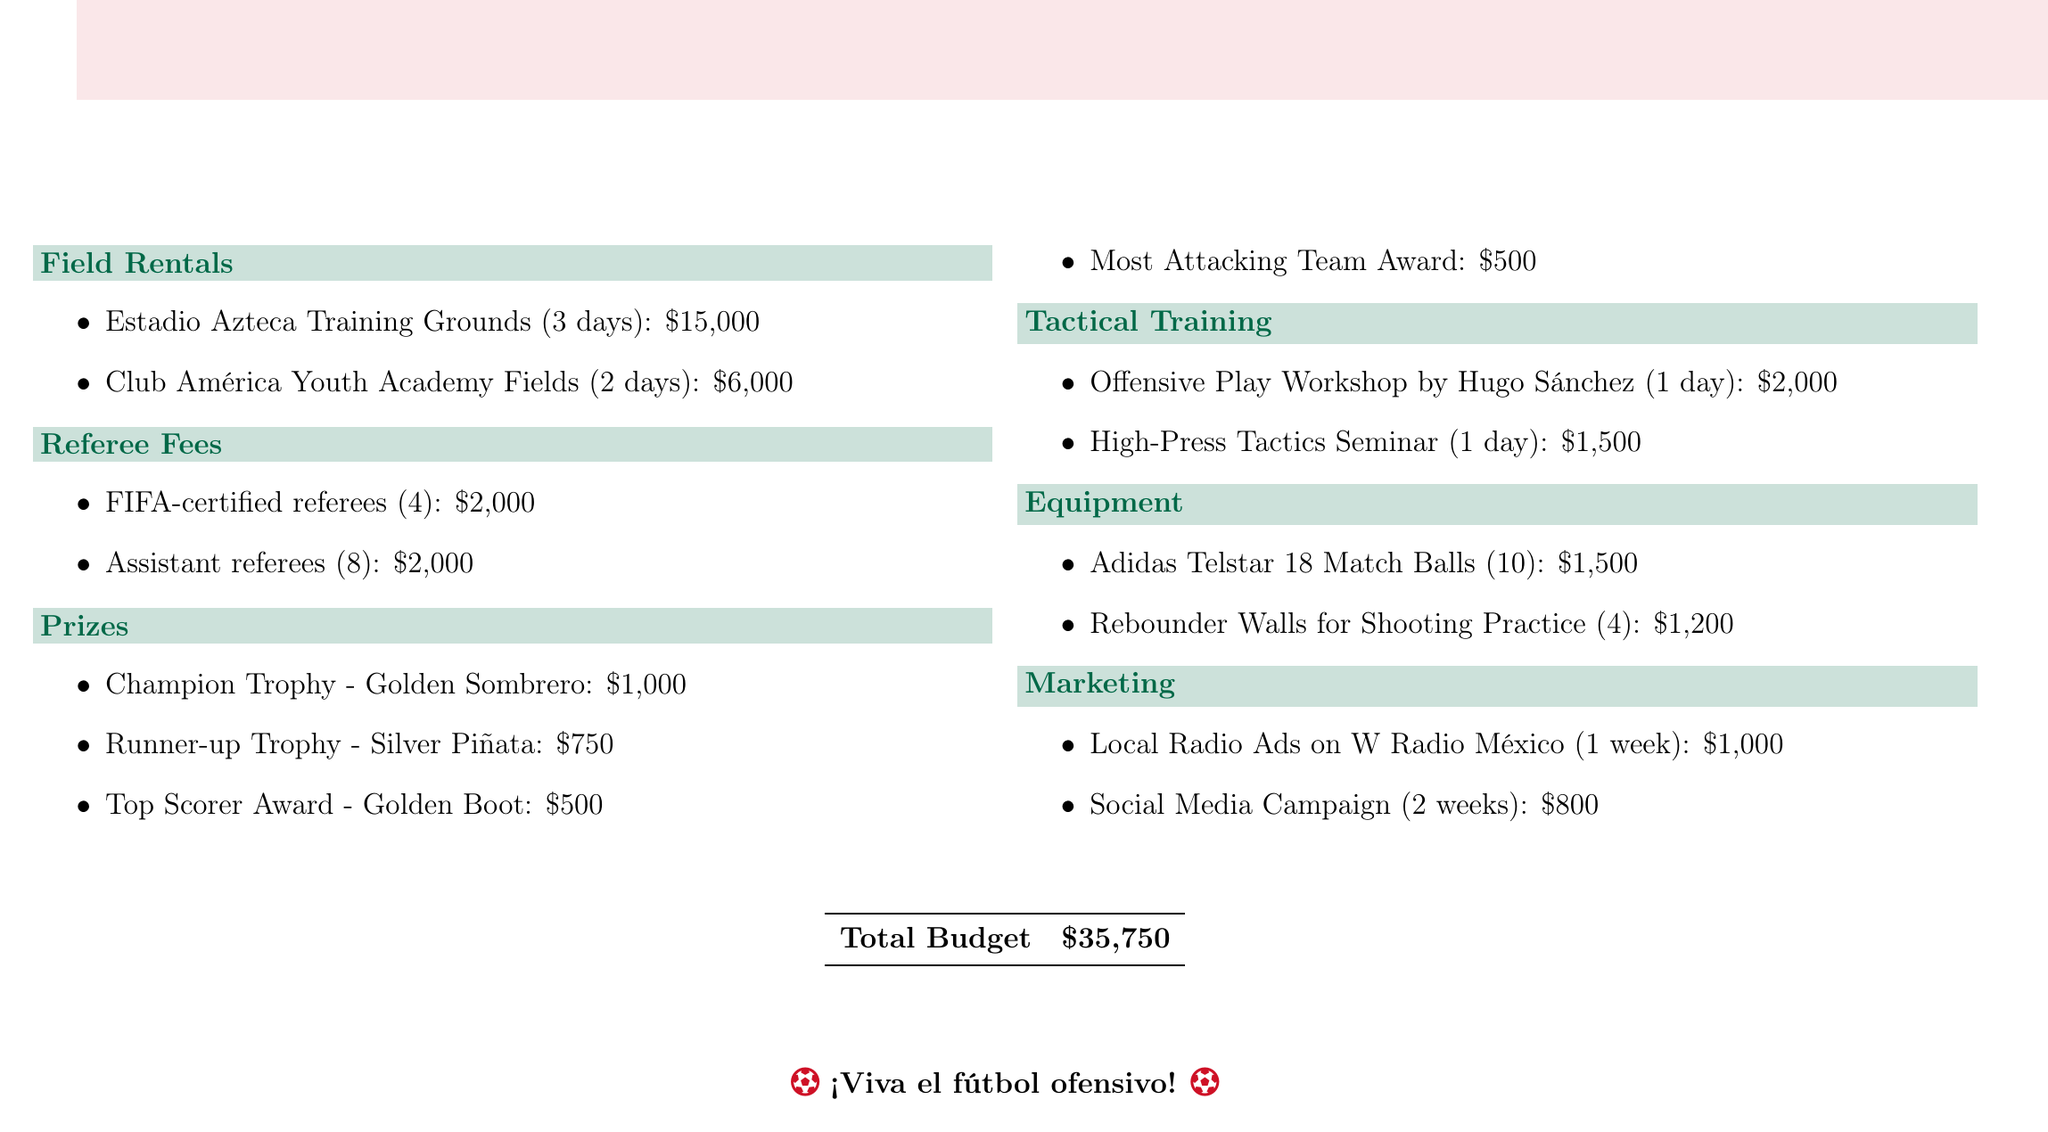What is the total budget? The total budget is provided at the bottom of the document, summarizing all expenses included.
Answer: $35,750 How much does it cost to rent Estadio Azteca Training Grounds? The cost for renting Estadio Azteca Training Grounds for 3 days is mentioned in the field rentals section.
Answer: $15,000 Who will conduct the Offensive Play Workshop? The document lists the individual responsible for this workshop, emphasizing the importance of offensive play.
Answer: Hugo Sánchez What is the cost of the Top Scorer Award? The document specifies the prize amount for the Top Scorer Award in the prizes section.
Answer: $500 How many days are the Club América Youth Academy Fields rented for? This is detailed in the field rentals section, indicating how long the fields are available for use.
Answer: 2 days What are the total referee fees? The total fees for both FIFA-certified and assistant referees are combined for quick reference in the referee fees section.
Answer: $4,000 What prize is awarded to the Most Attacking Team? The document specifies the title of the award intended for the most attacking team in the tournament.
Answer: Most Attacking Team Award What is the cost of the High-Press Tactics Seminar? The seminar cost is listed in the tactical training section, outlining the financial commitment needed for learning.
Answer: $1,500 What is included in the equipment costs? The equipment section briefly describes items that will be purchased for the tournament, focusing on improvements for offensive play.
Answer: Adidas Telstar 18 Match Balls and Rebounder Walls 